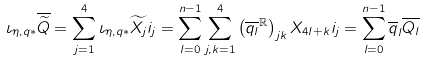<formula> <loc_0><loc_0><loc_500><loc_500>\iota _ { \eta , q * } \overline { \widetilde { Q } } = \sum _ { j = 1 } ^ { 4 } \iota _ { \eta , q * } \widetilde { X _ { j } } i _ { j } = \sum _ { l = 0 } ^ { n - 1 } \sum _ { j , k = 1 } ^ { 4 } \left ( \overline { q _ { l } } ^ { \mathbb { R } } \right ) _ { j k } X _ { 4 l + k } i _ { j } = \sum _ { l = 0 } ^ { n - 1 } \overline { q } _ { l } \overline { Q _ { l } }</formula> 